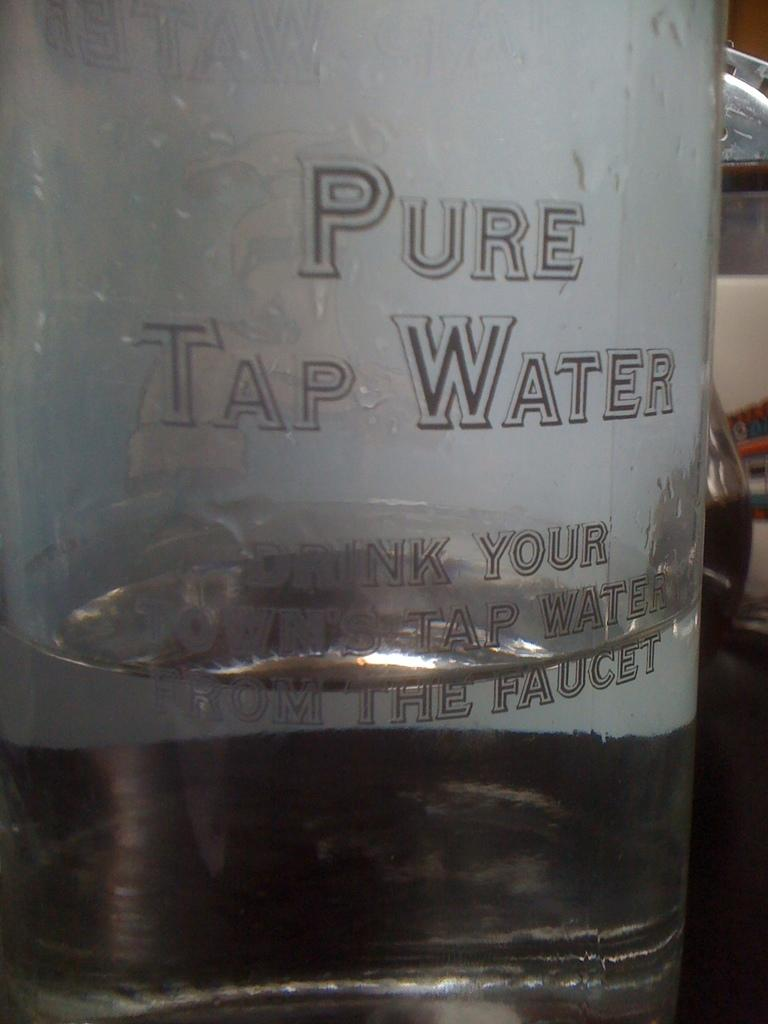Provide a one-sentence caption for the provided image. A large containter of Pure Tap Water is sitting on a table. 